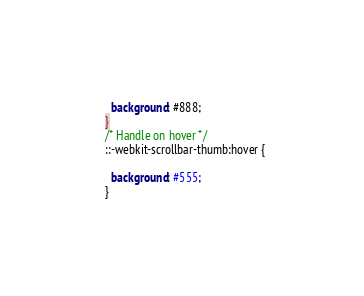<code> <loc_0><loc_0><loc_500><loc_500><_CSS_>    background: #888; 
  }
  /* Handle on hover */
  ::-webkit-scrollbar-thumb:hover {
    
    background: #555; 
  } </code> 